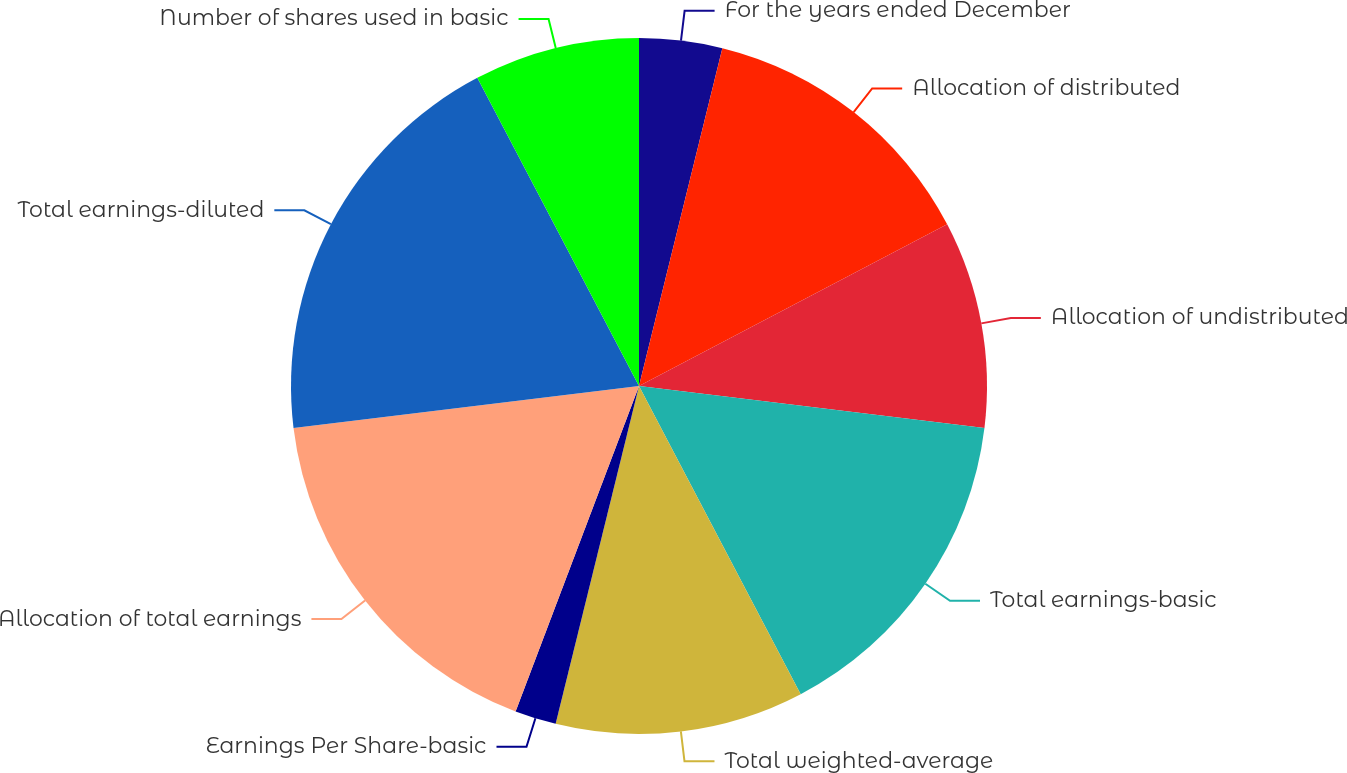<chart> <loc_0><loc_0><loc_500><loc_500><pie_chart><fcel>For the years ended December<fcel>Allocation of distributed<fcel>Allocation of undistributed<fcel>Total earnings-basic<fcel>Total weighted-average<fcel>Earnings Per Share-basic<fcel>Allocation of total earnings<fcel>Total earnings-diluted<fcel>Number of shares used in basic<nl><fcel>3.85%<fcel>13.46%<fcel>9.62%<fcel>15.38%<fcel>11.54%<fcel>1.92%<fcel>17.31%<fcel>19.23%<fcel>7.69%<nl></chart> 